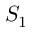<formula> <loc_0><loc_0><loc_500><loc_500>S _ { 1 }</formula> 